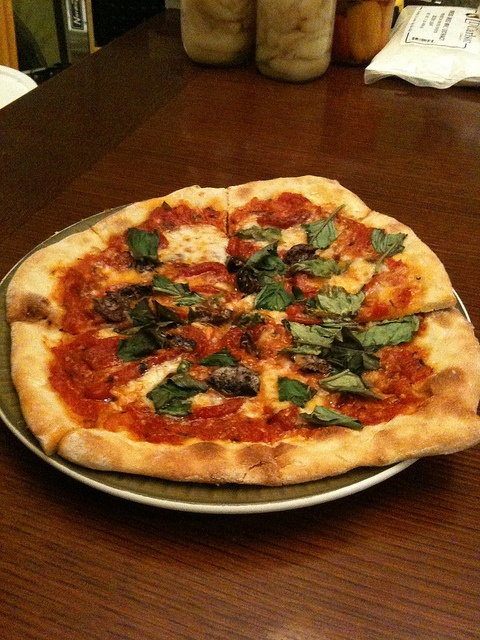Describe the objects in this image and their specific colors. I can see a pizza in olive, orange, brown, and black tones in this image. 